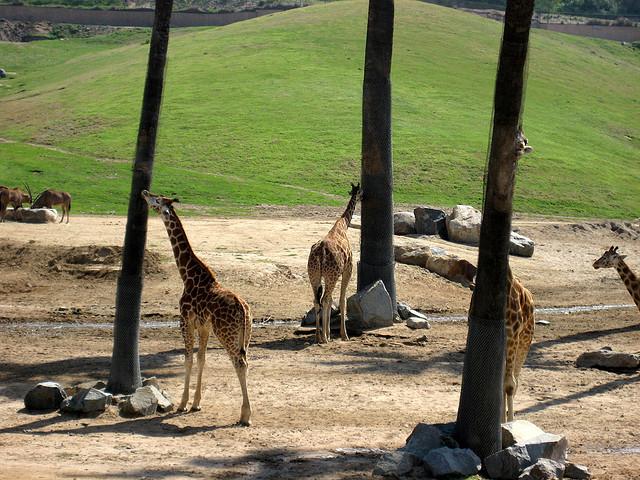How many giraffes are in the picture?
Keep it brief. 4. What is the color of the grass?
Short answer required. Green. How many trees are in the picture?
Short answer required. 3. 